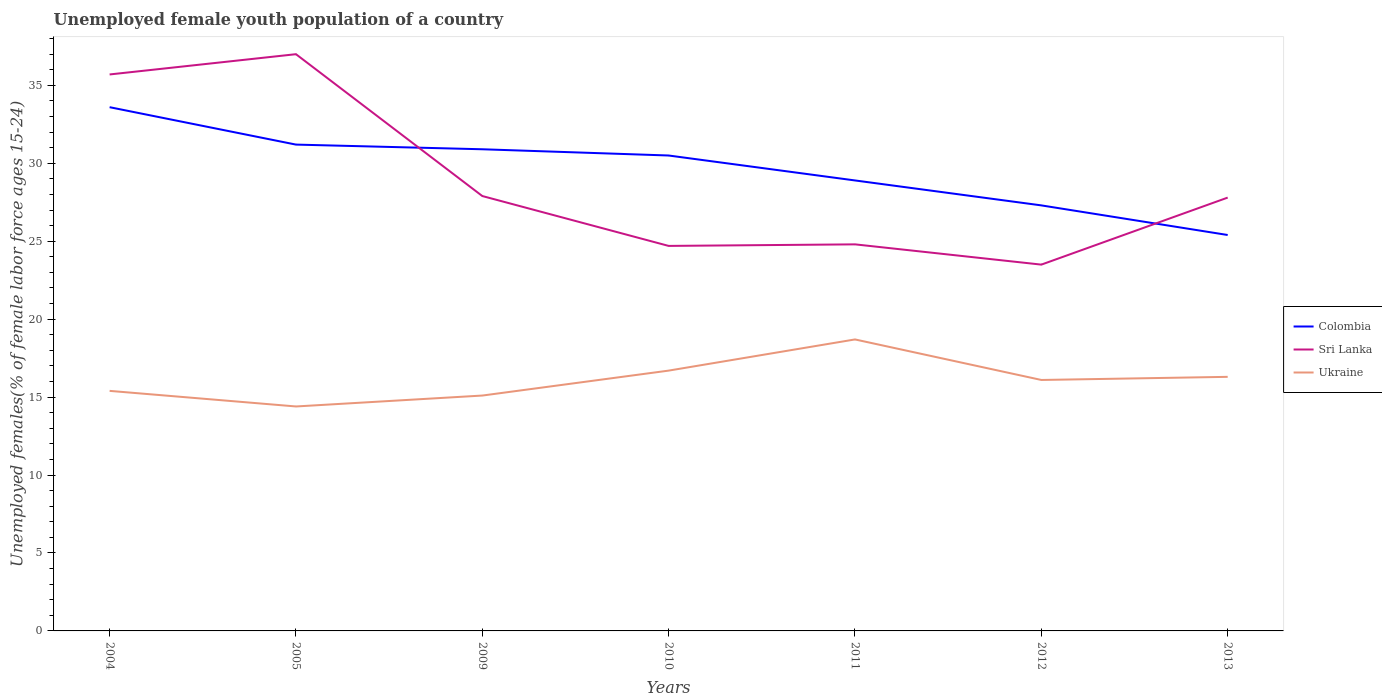How many different coloured lines are there?
Make the answer very short. 3. Does the line corresponding to Ukraine intersect with the line corresponding to Colombia?
Your response must be concise. No. Is the number of lines equal to the number of legend labels?
Provide a succinct answer. Yes. Across all years, what is the maximum percentage of unemployed female youth population in Colombia?
Ensure brevity in your answer.  25.4. What is the total percentage of unemployed female youth population in Sri Lanka in the graph?
Your answer should be very brief. 9.1. What is the difference between the highest and the second highest percentage of unemployed female youth population in Ukraine?
Give a very brief answer. 4.3. Is the percentage of unemployed female youth population in Ukraine strictly greater than the percentage of unemployed female youth population in Sri Lanka over the years?
Your response must be concise. Yes. How many lines are there?
Your answer should be very brief. 3. How many years are there in the graph?
Provide a short and direct response. 7. What is the difference between two consecutive major ticks on the Y-axis?
Offer a very short reply. 5. Are the values on the major ticks of Y-axis written in scientific E-notation?
Your response must be concise. No. Does the graph contain any zero values?
Provide a short and direct response. No. Where does the legend appear in the graph?
Your answer should be compact. Center right. What is the title of the graph?
Offer a very short reply. Unemployed female youth population of a country. What is the label or title of the Y-axis?
Your response must be concise. Unemployed females(% of female labor force ages 15-24). What is the Unemployed females(% of female labor force ages 15-24) in Colombia in 2004?
Make the answer very short. 33.6. What is the Unemployed females(% of female labor force ages 15-24) in Sri Lanka in 2004?
Your response must be concise. 35.7. What is the Unemployed females(% of female labor force ages 15-24) in Ukraine in 2004?
Give a very brief answer. 15.4. What is the Unemployed females(% of female labor force ages 15-24) in Colombia in 2005?
Make the answer very short. 31.2. What is the Unemployed females(% of female labor force ages 15-24) in Sri Lanka in 2005?
Offer a terse response. 37. What is the Unemployed females(% of female labor force ages 15-24) of Ukraine in 2005?
Ensure brevity in your answer.  14.4. What is the Unemployed females(% of female labor force ages 15-24) of Colombia in 2009?
Keep it short and to the point. 30.9. What is the Unemployed females(% of female labor force ages 15-24) in Sri Lanka in 2009?
Your response must be concise. 27.9. What is the Unemployed females(% of female labor force ages 15-24) of Ukraine in 2009?
Offer a terse response. 15.1. What is the Unemployed females(% of female labor force ages 15-24) in Colombia in 2010?
Give a very brief answer. 30.5. What is the Unemployed females(% of female labor force ages 15-24) in Sri Lanka in 2010?
Offer a very short reply. 24.7. What is the Unemployed females(% of female labor force ages 15-24) in Ukraine in 2010?
Your answer should be very brief. 16.7. What is the Unemployed females(% of female labor force ages 15-24) of Colombia in 2011?
Offer a very short reply. 28.9. What is the Unemployed females(% of female labor force ages 15-24) in Sri Lanka in 2011?
Keep it short and to the point. 24.8. What is the Unemployed females(% of female labor force ages 15-24) of Ukraine in 2011?
Provide a succinct answer. 18.7. What is the Unemployed females(% of female labor force ages 15-24) in Colombia in 2012?
Provide a succinct answer. 27.3. What is the Unemployed females(% of female labor force ages 15-24) of Ukraine in 2012?
Provide a succinct answer. 16.1. What is the Unemployed females(% of female labor force ages 15-24) in Colombia in 2013?
Your response must be concise. 25.4. What is the Unemployed females(% of female labor force ages 15-24) of Sri Lanka in 2013?
Your response must be concise. 27.8. What is the Unemployed females(% of female labor force ages 15-24) in Ukraine in 2013?
Provide a short and direct response. 16.3. Across all years, what is the maximum Unemployed females(% of female labor force ages 15-24) in Colombia?
Your answer should be very brief. 33.6. Across all years, what is the maximum Unemployed females(% of female labor force ages 15-24) in Sri Lanka?
Offer a very short reply. 37. Across all years, what is the maximum Unemployed females(% of female labor force ages 15-24) of Ukraine?
Your response must be concise. 18.7. Across all years, what is the minimum Unemployed females(% of female labor force ages 15-24) of Colombia?
Offer a terse response. 25.4. Across all years, what is the minimum Unemployed females(% of female labor force ages 15-24) of Ukraine?
Provide a short and direct response. 14.4. What is the total Unemployed females(% of female labor force ages 15-24) in Colombia in the graph?
Offer a terse response. 207.8. What is the total Unemployed females(% of female labor force ages 15-24) of Sri Lanka in the graph?
Give a very brief answer. 201.4. What is the total Unemployed females(% of female labor force ages 15-24) in Ukraine in the graph?
Provide a short and direct response. 112.7. What is the difference between the Unemployed females(% of female labor force ages 15-24) of Colombia in 2004 and that in 2005?
Ensure brevity in your answer.  2.4. What is the difference between the Unemployed females(% of female labor force ages 15-24) of Sri Lanka in 2004 and that in 2005?
Your answer should be very brief. -1.3. What is the difference between the Unemployed females(% of female labor force ages 15-24) of Ukraine in 2004 and that in 2005?
Your answer should be compact. 1. What is the difference between the Unemployed females(% of female labor force ages 15-24) of Ukraine in 2004 and that in 2009?
Your answer should be very brief. 0.3. What is the difference between the Unemployed females(% of female labor force ages 15-24) of Colombia in 2004 and that in 2010?
Offer a very short reply. 3.1. What is the difference between the Unemployed females(% of female labor force ages 15-24) in Colombia in 2004 and that in 2011?
Ensure brevity in your answer.  4.7. What is the difference between the Unemployed females(% of female labor force ages 15-24) of Colombia in 2004 and that in 2012?
Give a very brief answer. 6.3. What is the difference between the Unemployed females(% of female labor force ages 15-24) of Colombia in 2004 and that in 2013?
Make the answer very short. 8.2. What is the difference between the Unemployed females(% of female labor force ages 15-24) of Ukraine in 2004 and that in 2013?
Your answer should be very brief. -0.9. What is the difference between the Unemployed females(% of female labor force ages 15-24) in Colombia in 2005 and that in 2009?
Your answer should be very brief. 0.3. What is the difference between the Unemployed females(% of female labor force ages 15-24) of Sri Lanka in 2005 and that in 2009?
Give a very brief answer. 9.1. What is the difference between the Unemployed females(% of female labor force ages 15-24) of Ukraine in 2005 and that in 2009?
Offer a terse response. -0.7. What is the difference between the Unemployed females(% of female labor force ages 15-24) in Colombia in 2005 and that in 2010?
Make the answer very short. 0.7. What is the difference between the Unemployed females(% of female labor force ages 15-24) of Ukraine in 2005 and that in 2010?
Give a very brief answer. -2.3. What is the difference between the Unemployed females(% of female labor force ages 15-24) of Colombia in 2005 and that in 2011?
Make the answer very short. 2.3. What is the difference between the Unemployed females(% of female labor force ages 15-24) in Sri Lanka in 2005 and that in 2011?
Offer a very short reply. 12.2. What is the difference between the Unemployed females(% of female labor force ages 15-24) of Ukraine in 2005 and that in 2011?
Your answer should be compact. -4.3. What is the difference between the Unemployed females(% of female labor force ages 15-24) in Colombia in 2005 and that in 2012?
Your response must be concise. 3.9. What is the difference between the Unemployed females(% of female labor force ages 15-24) in Sri Lanka in 2005 and that in 2012?
Your response must be concise. 13.5. What is the difference between the Unemployed females(% of female labor force ages 15-24) of Ukraine in 2005 and that in 2013?
Ensure brevity in your answer.  -1.9. What is the difference between the Unemployed females(% of female labor force ages 15-24) of Colombia in 2009 and that in 2010?
Keep it short and to the point. 0.4. What is the difference between the Unemployed females(% of female labor force ages 15-24) in Sri Lanka in 2009 and that in 2011?
Provide a succinct answer. 3.1. What is the difference between the Unemployed females(% of female labor force ages 15-24) in Colombia in 2009 and that in 2012?
Provide a succinct answer. 3.6. What is the difference between the Unemployed females(% of female labor force ages 15-24) in Ukraine in 2009 and that in 2012?
Your answer should be compact. -1. What is the difference between the Unemployed females(% of female labor force ages 15-24) of Ukraine in 2010 and that in 2011?
Offer a very short reply. -2. What is the difference between the Unemployed females(% of female labor force ages 15-24) in Ukraine in 2010 and that in 2012?
Keep it short and to the point. 0.6. What is the difference between the Unemployed females(% of female labor force ages 15-24) of Sri Lanka in 2010 and that in 2013?
Offer a terse response. -3.1. What is the difference between the Unemployed females(% of female labor force ages 15-24) in Ukraine in 2010 and that in 2013?
Your answer should be compact. 0.4. What is the difference between the Unemployed females(% of female labor force ages 15-24) of Colombia in 2011 and that in 2012?
Keep it short and to the point. 1.6. What is the difference between the Unemployed females(% of female labor force ages 15-24) in Sri Lanka in 2011 and that in 2012?
Provide a short and direct response. 1.3. What is the difference between the Unemployed females(% of female labor force ages 15-24) of Colombia in 2011 and that in 2013?
Offer a very short reply. 3.5. What is the difference between the Unemployed females(% of female labor force ages 15-24) of Ukraine in 2011 and that in 2013?
Ensure brevity in your answer.  2.4. What is the difference between the Unemployed females(% of female labor force ages 15-24) of Colombia in 2012 and that in 2013?
Ensure brevity in your answer.  1.9. What is the difference between the Unemployed females(% of female labor force ages 15-24) in Sri Lanka in 2012 and that in 2013?
Your answer should be very brief. -4.3. What is the difference between the Unemployed females(% of female labor force ages 15-24) of Sri Lanka in 2004 and the Unemployed females(% of female labor force ages 15-24) of Ukraine in 2005?
Provide a short and direct response. 21.3. What is the difference between the Unemployed females(% of female labor force ages 15-24) in Colombia in 2004 and the Unemployed females(% of female labor force ages 15-24) in Ukraine in 2009?
Your response must be concise. 18.5. What is the difference between the Unemployed females(% of female labor force ages 15-24) of Sri Lanka in 2004 and the Unemployed females(% of female labor force ages 15-24) of Ukraine in 2009?
Make the answer very short. 20.6. What is the difference between the Unemployed females(% of female labor force ages 15-24) in Colombia in 2004 and the Unemployed females(% of female labor force ages 15-24) in Sri Lanka in 2010?
Keep it short and to the point. 8.9. What is the difference between the Unemployed females(% of female labor force ages 15-24) of Colombia in 2004 and the Unemployed females(% of female labor force ages 15-24) of Ukraine in 2010?
Offer a terse response. 16.9. What is the difference between the Unemployed females(% of female labor force ages 15-24) of Sri Lanka in 2004 and the Unemployed females(% of female labor force ages 15-24) of Ukraine in 2010?
Offer a terse response. 19. What is the difference between the Unemployed females(% of female labor force ages 15-24) of Colombia in 2004 and the Unemployed females(% of female labor force ages 15-24) of Sri Lanka in 2011?
Your response must be concise. 8.8. What is the difference between the Unemployed females(% of female labor force ages 15-24) in Colombia in 2004 and the Unemployed females(% of female labor force ages 15-24) in Ukraine in 2011?
Offer a terse response. 14.9. What is the difference between the Unemployed females(% of female labor force ages 15-24) in Colombia in 2004 and the Unemployed females(% of female labor force ages 15-24) in Sri Lanka in 2012?
Give a very brief answer. 10.1. What is the difference between the Unemployed females(% of female labor force ages 15-24) in Colombia in 2004 and the Unemployed females(% of female labor force ages 15-24) in Ukraine in 2012?
Provide a short and direct response. 17.5. What is the difference between the Unemployed females(% of female labor force ages 15-24) of Sri Lanka in 2004 and the Unemployed females(% of female labor force ages 15-24) of Ukraine in 2012?
Your response must be concise. 19.6. What is the difference between the Unemployed females(% of female labor force ages 15-24) in Colombia in 2004 and the Unemployed females(% of female labor force ages 15-24) in Sri Lanka in 2013?
Your answer should be compact. 5.8. What is the difference between the Unemployed females(% of female labor force ages 15-24) of Colombia in 2004 and the Unemployed females(% of female labor force ages 15-24) of Ukraine in 2013?
Keep it short and to the point. 17.3. What is the difference between the Unemployed females(% of female labor force ages 15-24) in Colombia in 2005 and the Unemployed females(% of female labor force ages 15-24) in Ukraine in 2009?
Give a very brief answer. 16.1. What is the difference between the Unemployed females(% of female labor force ages 15-24) of Sri Lanka in 2005 and the Unemployed females(% of female labor force ages 15-24) of Ukraine in 2009?
Offer a very short reply. 21.9. What is the difference between the Unemployed females(% of female labor force ages 15-24) in Sri Lanka in 2005 and the Unemployed females(% of female labor force ages 15-24) in Ukraine in 2010?
Offer a very short reply. 20.3. What is the difference between the Unemployed females(% of female labor force ages 15-24) in Colombia in 2005 and the Unemployed females(% of female labor force ages 15-24) in Sri Lanka in 2011?
Your answer should be very brief. 6.4. What is the difference between the Unemployed females(% of female labor force ages 15-24) of Sri Lanka in 2005 and the Unemployed females(% of female labor force ages 15-24) of Ukraine in 2011?
Keep it short and to the point. 18.3. What is the difference between the Unemployed females(% of female labor force ages 15-24) of Colombia in 2005 and the Unemployed females(% of female labor force ages 15-24) of Sri Lanka in 2012?
Offer a very short reply. 7.7. What is the difference between the Unemployed females(% of female labor force ages 15-24) of Sri Lanka in 2005 and the Unemployed females(% of female labor force ages 15-24) of Ukraine in 2012?
Give a very brief answer. 20.9. What is the difference between the Unemployed females(% of female labor force ages 15-24) in Colombia in 2005 and the Unemployed females(% of female labor force ages 15-24) in Ukraine in 2013?
Ensure brevity in your answer.  14.9. What is the difference between the Unemployed females(% of female labor force ages 15-24) in Sri Lanka in 2005 and the Unemployed females(% of female labor force ages 15-24) in Ukraine in 2013?
Give a very brief answer. 20.7. What is the difference between the Unemployed females(% of female labor force ages 15-24) in Colombia in 2009 and the Unemployed females(% of female labor force ages 15-24) in Sri Lanka in 2010?
Your answer should be very brief. 6.2. What is the difference between the Unemployed females(% of female labor force ages 15-24) in Colombia in 2009 and the Unemployed females(% of female labor force ages 15-24) in Ukraine in 2011?
Give a very brief answer. 12.2. What is the difference between the Unemployed females(% of female labor force ages 15-24) of Colombia in 2009 and the Unemployed females(% of female labor force ages 15-24) of Sri Lanka in 2012?
Offer a very short reply. 7.4. What is the difference between the Unemployed females(% of female labor force ages 15-24) in Colombia in 2009 and the Unemployed females(% of female labor force ages 15-24) in Ukraine in 2012?
Ensure brevity in your answer.  14.8. What is the difference between the Unemployed females(% of female labor force ages 15-24) of Sri Lanka in 2009 and the Unemployed females(% of female labor force ages 15-24) of Ukraine in 2012?
Give a very brief answer. 11.8. What is the difference between the Unemployed females(% of female labor force ages 15-24) in Colombia in 2009 and the Unemployed females(% of female labor force ages 15-24) in Sri Lanka in 2013?
Make the answer very short. 3.1. What is the difference between the Unemployed females(% of female labor force ages 15-24) in Sri Lanka in 2009 and the Unemployed females(% of female labor force ages 15-24) in Ukraine in 2013?
Make the answer very short. 11.6. What is the difference between the Unemployed females(% of female labor force ages 15-24) in Colombia in 2010 and the Unemployed females(% of female labor force ages 15-24) in Ukraine in 2011?
Your answer should be compact. 11.8. What is the difference between the Unemployed females(% of female labor force ages 15-24) in Colombia in 2010 and the Unemployed females(% of female labor force ages 15-24) in Ukraine in 2012?
Provide a succinct answer. 14.4. What is the difference between the Unemployed females(% of female labor force ages 15-24) in Colombia in 2010 and the Unemployed females(% of female labor force ages 15-24) in Ukraine in 2013?
Your response must be concise. 14.2. What is the difference between the Unemployed females(% of female labor force ages 15-24) in Colombia in 2011 and the Unemployed females(% of female labor force ages 15-24) in Ukraine in 2012?
Your answer should be compact. 12.8. What is the difference between the Unemployed females(% of female labor force ages 15-24) of Colombia in 2011 and the Unemployed females(% of female labor force ages 15-24) of Ukraine in 2013?
Ensure brevity in your answer.  12.6. What is the difference between the Unemployed females(% of female labor force ages 15-24) of Sri Lanka in 2011 and the Unemployed females(% of female labor force ages 15-24) of Ukraine in 2013?
Keep it short and to the point. 8.5. What is the difference between the Unemployed females(% of female labor force ages 15-24) of Sri Lanka in 2012 and the Unemployed females(% of female labor force ages 15-24) of Ukraine in 2013?
Your answer should be compact. 7.2. What is the average Unemployed females(% of female labor force ages 15-24) in Colombia per year?
Make the answer very short. 29.69. What is the average Unemployed females(% of female labor force ages 15-24) in Sri Lanka per year?
Make the answer very short. 28.77. What is the average Unemployed females(% of female labor force ages 15-24) in Ukraine per year?
Keep it short and to the point. 16.1. In the year 2004, what is the difference between the Unemployed females(% of female labor force ages 15-24) in Colombia and Unemployed females(% of female labor force ages 15-24) in Sri Lanka?
Offer a terse response. -2.1. In the year 2004, what is the difference between the Unemployed females(% of female labor force ages 15-24) of Colombia and Unemployed females(% of female labor force ages 15-24) of Ukraine?
Keep it short and to the point. 18.2. In the year 2004, what is the difference between the Unemployed females(% of female labor force ages 15-24) of Sri Lanka and Unemployed females(% of female labor force ages 15-24) of Ukraine?
Give a very brief answer. 20.3. In the year 2005, what is the difference between the Unemployed females(% of female labor force ages 15-24) in Colombia and Unemployed females(% of female labor force ages 15-24) in Sri Lanka?
Provide a short and direct response. -5.8. In the year 2005, what is the difference between the Unemployed females(% of female labor force ages 15-24) in Sri Lanka and Unemployed females(% of female labor force ages 15-24) in Ukraine?
Give a very brief answer. 22.6. In the year 2009, what is the difference between the Unemployed females(% of female labor force ages 15-24) in Colombia and Unemployed females(% of female labor force ages 15-24) in Ukraine?
Give a very brief answer. 15.8. In the year 2011, what is the difference between the Unemployed females(% of female labor force ages 15-24) of Colombia and Unemployed females(% of female labor force ages 15-24) of Sri Lanka?
Give a very brief answer. 4.1. In the year 2012, what is the difference between the Unemployed females(% of female labor force ages 15-24) in Colombia and Unemployed females(% of female labor force ages 15-24) in Sri Lanka?
Provide a succinct answer. 3.8. In the year 2012, what is the difference between the Unemployed females(% of female labor force ages 15-24) of Colombia and Unemployed females(% of female labor force ages 15-24) of Ukraine?
Offer a very short reply. 11.2. In the year 2012, what is the difference between the Unemployed females(% of female labor force ages 15-24) of Sri Lanka and Unemployed females(% of female labor force ages 15-24) of Ukraine?
Keep it short and to the point. 7.4. In the year 2013, what is the difference between the Unemployed females(% of female labor force ages 15-24) in Colombia and Unemployed females(% of female labor force ages 15-24) in Ukraine?
Your response must be concise. 9.1. In the year 2013, what is the difference between the Unemployed females(% of female labor force ages 15-24) of Sri Lanka and Unemployed females(% of female labor force ages 15-24) of Ukraine?
Make the answer very short. 11.5. What is the ratio of the Unemployed females(% of female labor force ages 15-24) of Colombia in 2004 to that in 2005?
Make the answer very short. 1.08. What is the ratio of the Unemployed females(% of female labor force ages 15-24) of Sri Lanka in 2004 to that in 2005?
Provide a succinct answer. 0.96. What is the ratio of the Unemployed females(% of female labor force ages 15-24) of Ukraine in 2004 to that in 2005?
Offer a terse response. 1.07. What is the ratio of the Unemployed females(% of female labor force ages 15-24) of Colombia in 2004 to that in 2009?
Provide a short and direct response. 1.09. What is the ratio of the Unemployed females(% of female labor force ages 15-24) in Sri Lanka in 2004 to that in 2009?
Make the answer very short. 1.28. What is the ratio of the Unemployed females(% of female labor force ages 15-24) of Ukraine in 2004 to that in 2009?
Make the answer very short. 1.02. What is the ratio of the Unemployed females(% of female labor force ages 15-24) of Colombia in 2004 to that in 2010?
Offer a terse response. 1.1. What is the ratio of the Unemployed females(% of female labor force ages 15-24) in Sri Lanka in 2004 to that in 2010?
Provide a succinct answer. 1.45. What is the ratio of the Unemployed females(% of female labor force ages 15-24) of Ukraine in 2004 to that in 2010?
Provide a short and direct response. 0.92. What is the ratio of the Unemployed females(% of female labor force ages 15-24) of Colombia in 2004 to that in 2011?
Your response must be concise. 1.16. What is the ratio of the Unemployed females(% of female labor force ages 15-24) of Sri Lanka in 2004 to that in 2011?
Ensure brevity in your answer.  1.44. What is the ratio of the Unemployed females(% of female labor force ages 15-24) in Ukraine in 2004 to that in 2011?
Offer a very short reply. 0.82. What is the ratio of the Unemployed females(% of female labor force ages 15-24) in Colombia in 2004 to that in 2012?
Your answer should be very brief. 1.23. What is the ratio of the Unemployed females(% of female labor force ages 15-24) in Sri Lanka in 2004 to that in 2012?
Offer a very short reply. 1.52. What is the ratio of the Unemployed females(% of female labor force ages 15-24) in Ukraine in 2004 to that in 2012?
Offer a terse response. 0.96. What is the ratio of the Unemployed females(% of female labor force ages 15-24) of Colombia in 2004 to that in 2013?
Provide a short and direct response. 1.32. What is the ratio of the Unemployed females(% of female labor force ages 15-24) in Sri Lanka in 2004 to that in 2013?
Your response must be concise. 1.28. What is the ratio of the Unemployed females(% of female labor force ages 15-24) of Ukraine in 2004 to that in 2013?
Keep it short and to the point. 0.94. What is the ratio of the Unemployed females(% of female labor force ages 15-24) of Colombia in 2005 to that in 2009?
Your answer should be very brief. 1.01. What is the ratio of the Unemployed females(% of female labor force ages 15-24) of Sri Lanka in 2005 to that in 2009?
Provide a succinct answer. 1.33. What is the ratio of the Unemployed females(% of female labor force ages 15-24) of Ukraine in 2005 to that in 2009?
Your response must be concise. 0.95. What is the ratio of the Unemployed females(% of female labor force ages 15-24) in Colombia in 2005 to that in 2010?
Provide a short and direct response. 1.02. What is the ratio of the Unemployed females(% of female labor force ages 15-24) in Sri Lanka in 2005 to that in 2010?
Your answer should be very brief. 1.5. What is the ratio of the Unemployed females(% of female labor force ages 15-24) of Ukraine in 2005 to that in 2010?
Your response must be concise. 0.86. What is the ratio of the Unemployed females(% of female labor force ages 15-24) in Colombia in 2005 to that in 2011?
Give a very brief answer. 1.08. What is the ratio of the Unemployed females(% of female labor force ages 15-24) in Sri Lanka in 2005 to that in 2011?
Offer a terse response. 1.49. What is the ratio of the Unemployed females(% of female labor force ages 15-24) in Ukraine in 2005 to that in 2011?
Offer a terse response. 0.77. What is the ratio of the Unemployed females(% of female labor force ages 15-24) in Colombia in 2005 to that in 2012?
Your response must be concise. 1.14. What is the ratio of the Unemployed females(% of female labor force ages 15-24) in Sri Lanka in 2005 to that in 2012?
Your answer should be very brief. 1.57. What is the ratio of the Unemployed females(% of female labor force ages 15-24) of Ukraine in 2005 to that in 2012?
Your answer should be compact. 0.89. What is the ratio of the Unemployed females(% of female labor force ages 15-24) in Colombia in 2005 to that in 2013?
Offer a very short reply. 1.23. What is the ratio of the Unemployed females(% of female labor force ages 15-24) of Sri Lanka in 2005 to that in 2013?
Ensure brevity in your answer.  1.33. What is the ratio of the Unemployed females(% of female labor force ages 15-24) in Ukraine in 2005 to that in 2013?
Offer a terse response. 0.88. What is the ratio of the Unemployed females(% of female labor force ages 15-24) of Colombia in 2009 to that in 2010?
Ensure brevity in your answer.  1.01. What is the ratio of the Unemployed females(% of female labor force ages 15-24) in Sri Lanka in 2009 to that in 2010?
Give a very brief answer. 1.13. What is the ratio of the Unemployed females(% of female labor force ages 15-24) in Ukraine in 2009 to that in 2010?
Provide a short and direct response. 0.9. What is the ratio of the Unemployed females(% of female labor force ages 15-24) of Colombia in 2009 to that in 2011?
Ensure brevity in your answer.  1.07. What is the ratio of the Unemployed females(% of female labor force ages 15-24) in Ukraine in 2009 to that in 2011?
Offer a very short reply. 0.81. What is the ratio of the Unemployed females(% of female labor force ages 15-24) of Colombia in 2009 to that in 2012?
Offer a very short reply. 1.13. What is the ratio of the Unemployed females(% of female labor force ages 15-24) of Sri Lanka in 2009 to that in 2012?
Keep it short and to the point. 1.19. What is the ratio of the Unemployed females(% of female labor force ages 15-24) in Ukraine in 2009 to that in 2012?
Give a very brief answer. 0.94. What is the ratio of the Unemployed females(% of female labor force ages 15-24) of Colombia in 2009 to that in 2013?
Your answer should be very brief. 1.22. What is the ratio of the Unemployed females(% of female labor force ages 15-24) in Ukraine in 2009 to that in 2013?
Provide a short and direct response. 0.93. What is the ratio of the Unemployed females(% of female labor force ages 15-24) of Colombia in 2010 to that in 2011?
Provide a short and direct response. 1.06. What is the ratio of the Unemployed females(% of female labor force ages 15-24) of Ukraine in 2010 to that in 2011?
Provide a succinct answer. 0.89. What is the ratio of the Unemployed females(% of female labor force ages 15-24) of Colombia in 2010 to that in 2012?
Your answer should be compact. 1.12. What is the ratio of the Unemployed females(% of female labor force ages 15-24) of Sri Lanka in 2010 to that in 2012?
Your answer should be very brief. 1.05. What is the ratio of the Unemployed females(% of female labor force ages 15-24) of Ukraine in 2010 to that in 2012?
Provide a succinct answer. 1.04. What is the ratio of the Unemployed females(% of female labor force ages 15-24) in Colombia in 2010 to that in 2013?
Offer a very short reply. 1.2. What is the ratio of the Unemployed females(% of female labor force ages 15-24) of Sri Lanka in 2010 to that in 2013?
Your answer should be very brief. 0.89. What is the ratio of the Unemployed females(% of female labor force ages 15-24) in Ukraine in 2010 to that in 2013?
Your response must be concise. 1.02. What is the ratio of the Unemployed females(% of female labor force ages 15-24) of Colombia in 2011 to that in 2012?
Your answer should be very brief. 1.06. What is the ratio of the Unemployed females(% of female labor force ages 15-24) of Sri Lanka in 2011 to that in 2012?
Provide a succinct answer. 1.06. What is the ratio of the Unemployed females(% of female labor force ages 15-24) of Ukraine in 2011 to that in 2012?
Ensure brevity in your answer.  1.16. What is the ratio of the Unemployed females(% of female labor force ages 15-24) in Colombia in 2011 to that in 2013?
Your answer should be compact. 1.14. What is the ratio of the Unemployed females(% of female labor force ages 15-24) in Sri Lanka in 2011 to that in 2013?
Make the answer very short. 0.89. What is the ratio of the Unemployed females(% of female labor force ages 15-24) of Ukraine in 2011 to that in 2013?
Provide a succinct answer. 1.15. What is the ratio of the Unemployed females(% of female labor force ages 15-24) of Colombia in 2012 to that in 2013?
Offer a very short reply. 1.07. What is the ratio of the Unemployed females(% of female labor force ages 15-24) of Sri Lanka in 2012 to that in 2013?
Offer a very short reply. 0.85. What is the difference between the highest and the second highest Unemployed females(% of female labor force ages 15-24) in Sri Lanka?
Ensure brevity in your answer.  1.3. What is the difference between the highest and the second highest Unemployed females(% of female labor force ages 15-24) of Ukraine?
Your answer should be very brief. 2. What is the difference between the highest and the lowest Unemployed females(% of female labor force ages 15-24) of Colombia?
Offer a very short reply. 8.2. What is the difference between the highest and the lowest Unemployed females(% of female labor force ages 15-24) of Sri Lanka?
Offer a terse response. 13.5. What is the difference between the highest and the lowest Unemployed females(% of female labor force ages 15-24) of Ukraine?
Offer a terse response. 4.3. 